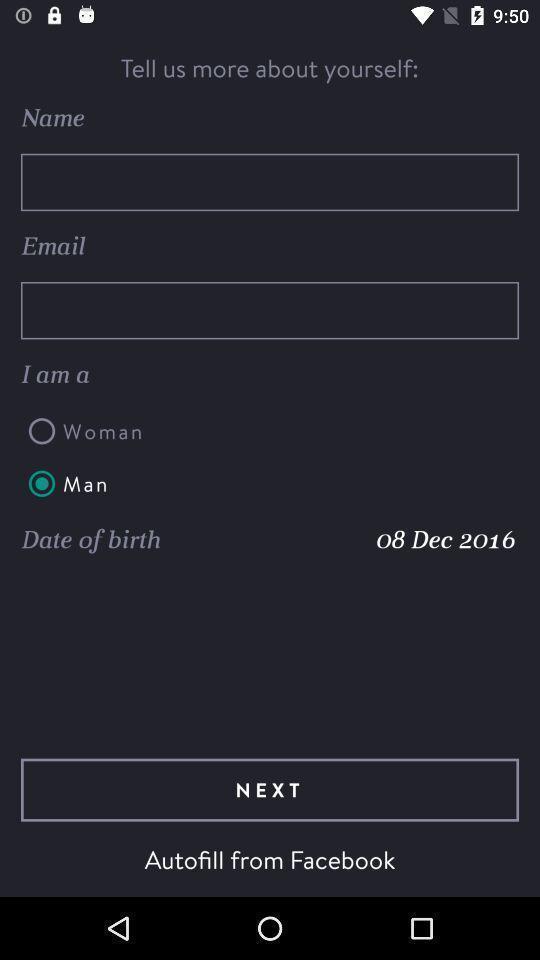What can you discern from this picture? Screen showing profile page. 